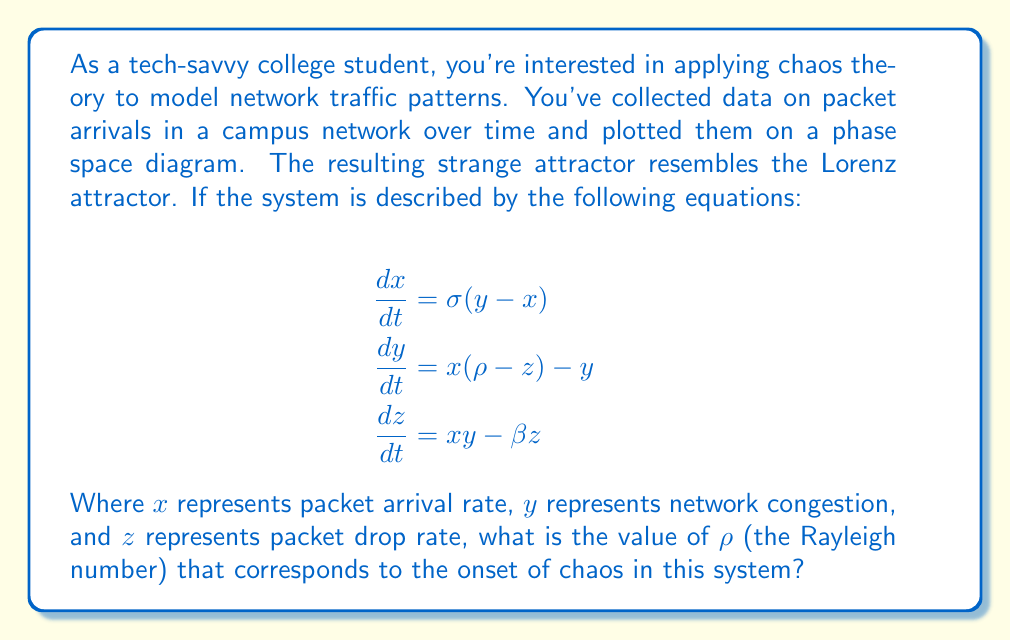Can you answer this question? To solve this problem, we need to understand the Lorenz system and the conditions for the onset of chaos:

1) The Lorenz system is a set of ordinary differential equations that exhibit chaotic behavior for certain parameter values.

2) The parameter $\rho$ is known as the Rayleigh number, and it plays a crucial role in determining the system's behavior.

3) The onset of chaos in the Lorenz system occurs when $\rho$ exceeds a critical value.

4) This critical value is determined by the other parameters in the system, specifically $\sigma$ and $\beta$.

5) The condition for the onset of chaos is given by:

   $$\rho > \rho_c = \sigma \frac{\sigma + \beta + 3}{\sigma - \beta - 1}$$

6) In the original Lorenz system, the typical values are $\sigma = 10$ and $\beta = 8/3$.

7) Substituting these values into the equation:

   $$\rho_c = 10 \frac{10 + 8/3 + 3}{10 - 8/3 - 1}$$

8) Simplifying:
   
   $$\rho_c = 10 \frac{43/3}{19/3} = 10 \frac{43}{19} \approx 22.6$$

Therefore, the onset of chaos occurs when $\rho$ exceeds approximately 22.6.
Answer: $\rho > 22.6$ 